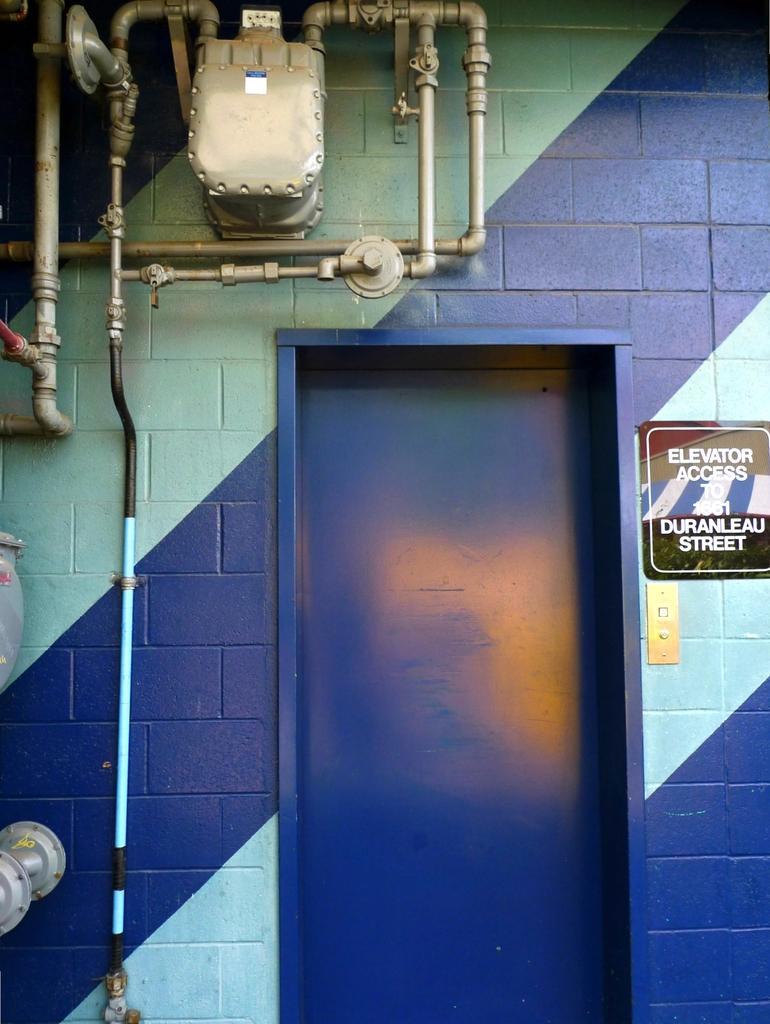Please provide a concise description of this image. In this image there is a wall for that wall there is a door and a board, on that board there is some text and there are pipes. 